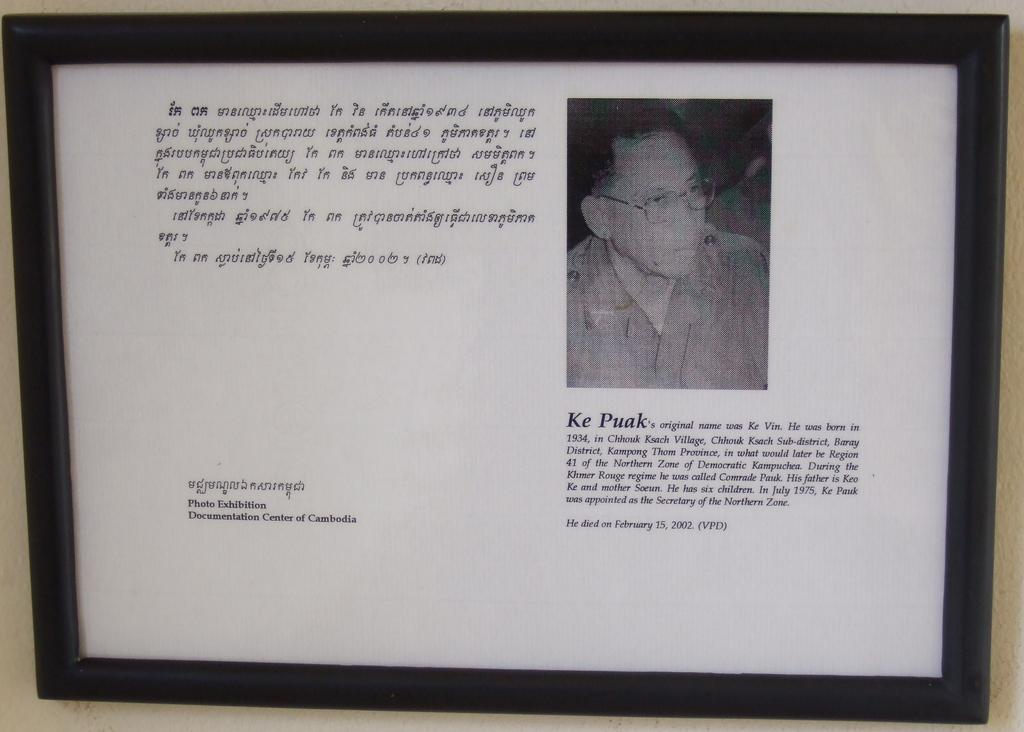Provide a one-sentence caption for the provided image. A picture frame hangs on a wall with a picture of a man name Ke Puak. 